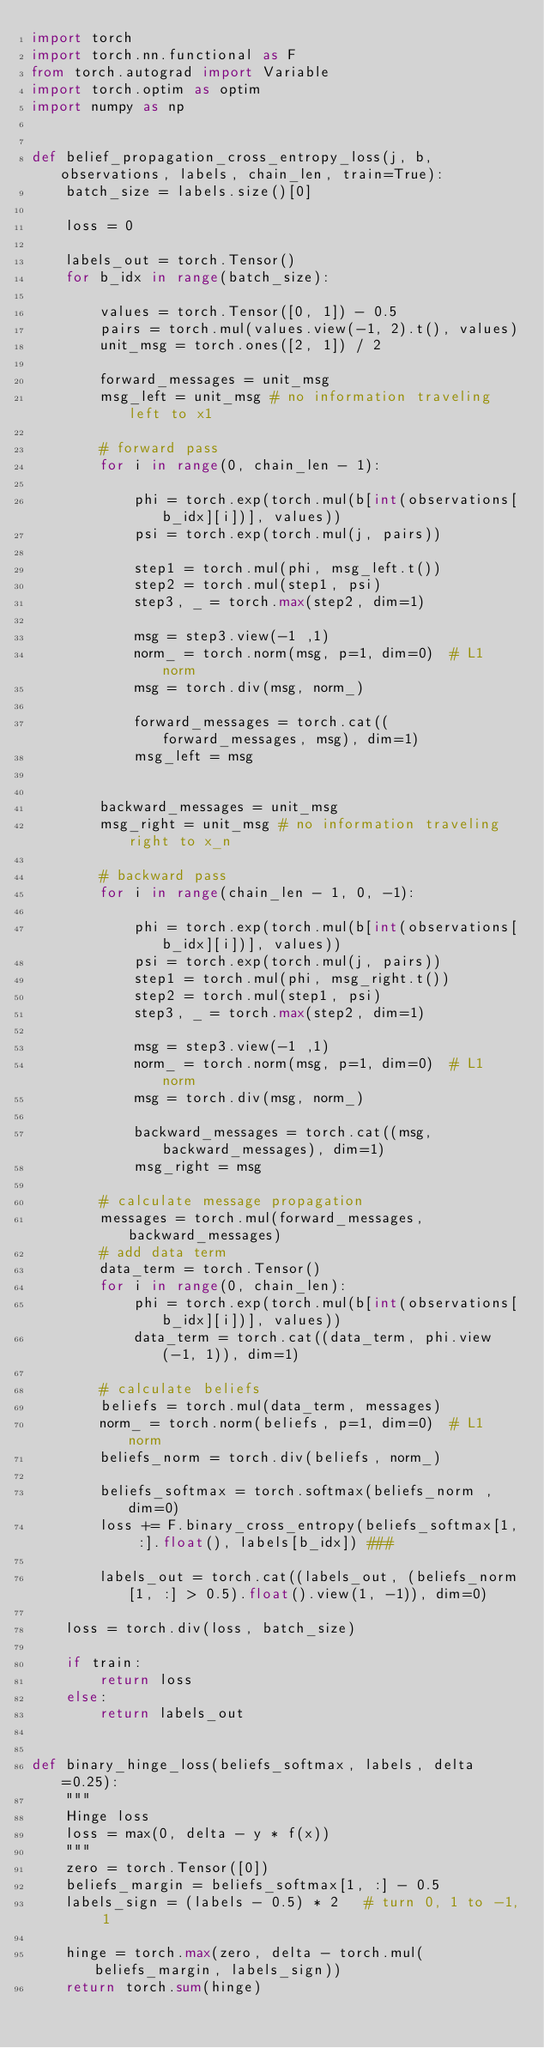<code> <loc_0><loc_0><loc_500><loc_500><_Python_>import torch
import torch.nn.functional as F
from torch.autograd import Variable
import torch.optim as optim
import numpy as np


def belief_propagation_cross_entropy_loss(j, b, observations, labels, chain_len, train=True):
    batch_size = labels.size()[0]
    
    loss = 0
    
    labels_out = torch.Tensor()
    for b_idx in range(batch_size):

        values = torch.Tensor([0, 1]) - 0.5
        pairs = torch.mul(values.view(-1, 2).t(), values)
        unit_msg = torch.ones([2, 1]) / 2
        
        forward_messages = unit_msg
        msg_left = unit_msg # no information traveling left to x1
        
        # forward pass    
        for i in range(0, chain_len - 1):
            
            phi = torch.exp(torch.mul(b[int(observations[b_idx][i])], values))
            psi = torch.exp(torch.mul(j, pairs))
  
            step1 = torch.mul(phi, msg_left.t())
            step2 = torch.mul(step1, psi)
            step3, _ = torch.max(step2, dim=1)

            msg = step3.view(-1 ,1)
            norm_ = torch.norm(msg, p=1, dim=0)  # L1 norm
            msg = torch.div(msg, norm_)
            
            forward_messages = torch.cat((forward_messages, msg), dim=1)    
            msg_left = msg
        
        
        backward_messages = unit_msg
        msg_right = unit_msg # no information traveling right to x_n
        
        # backward pass    
        for i in range(chain_len - 1, 0, -1):

            phi = torch.exp(torch.mul(b[int(observations[b_idx][i])], values))
            psi = torch.exp(torch.mul(j, pairs))
            step1 = torch.mul(phi, msg_right.t())
            step2 = torch.mul(step1, psi)
            step3, _ = torch.max(step2, dim=1)

            msg = step3.view(-1 ,1)
            norm_ = torch.norm(msg, p=1, dim=0)  # L1 norm
            msg = torch.div(msg, norm_)
            
            backward_messages = torch.cat((msg, backward_messages), dim=1)    
            msg_right = msg

        # calculate message propagation
        messages = torch.mul(forward_messages, backward_messages)
        # add data term
        data_term = torch.Tensor()
        for i in range(0, chain_len):
            phi = torch.exp(torch.mul(b[int(observations[b_idx][i])], values))
            data_term = torch.cat((data_term, phi.view(-1, 1)), dim=1)
        
        # calculate beliefs
        beliefs = torch.mul(data_term, messages)
        norm_ = torch.norm(beliefs, p=1, dim=0)  # L1 norm
        beliefs_norm = torch.div(beliefs, norm_)
        
        beliefs_softmax = torch.softmax(beliefs_norm , dim=0)
        loss += F.binary_cross_entropy(beliefs_softmax[1, :].float(), labels[b_idx]) ###
        
        labels_out = torch.cat((labels_out, (beliefs_norm[1, :] > 0.5).float().view(1, -1)), dim=0)
        
    loss = torch.div(loss, batch_size)
    
    if train:
        return loss
    else:
        return labels_out
        

def binary_hinge_loss(beliefs_softmax, labels, delta=0.25):
    """
    Hinge loss
    loss = max(0, delta - y * f(x))
    """
    zero = torch.Tensor([0])
    beliefs_margin = beliefs_softmax[1, :] - 0.5
    labels_sign = (labels - 0.5) * 2   # turn 0, 1 to -1, 1
    
    hinge = torch.max(zero, delta - torch.mul(beliefs_margin, labels_sign))
    return torch.sum(hinge)
    </code> 